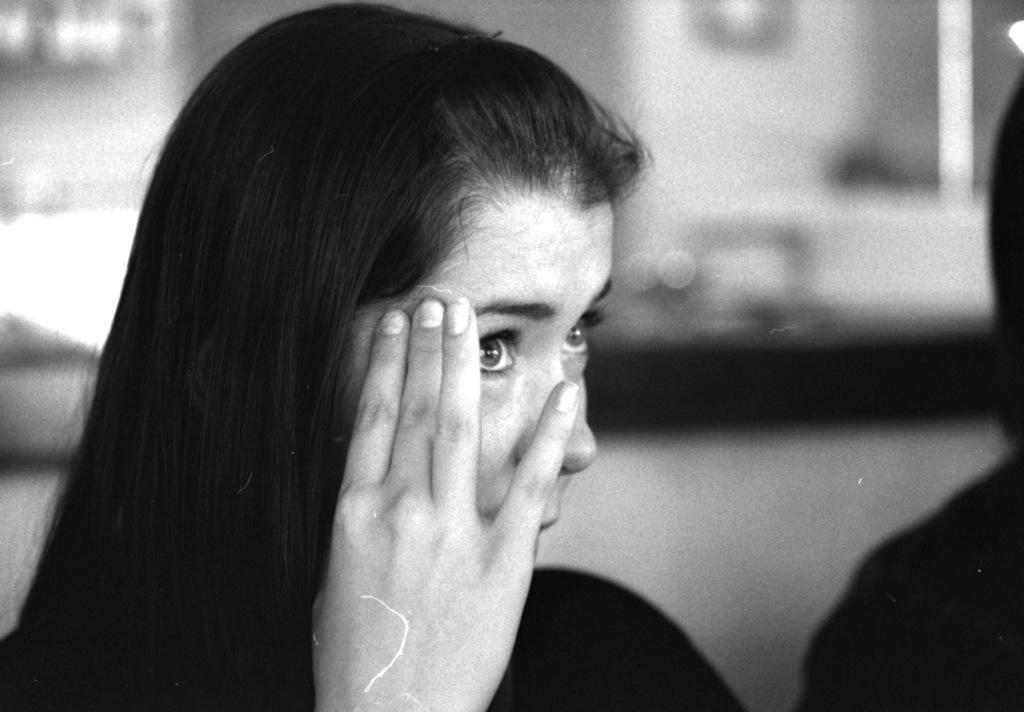Who is present in the image? There is a woman in the image. What can be seen on the right side of the image? There is a black color thing on the right side of the image. What is the color scheme of the image? The image is black and white in color. How many babies are present in the image? There are no babies present in the image. What is the woman's opinion on the topic of birth in the image? The image does not provide any information about the woman's opinion on the topic of birth. 